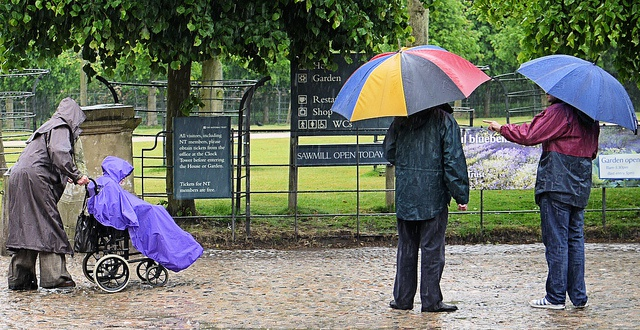Describe the objects in this image and their specific colors. I can see people in darkgreen, black, navy, blue, and gray tones, people in darkgreen, black, navy, darkblue, and gray tones, people in darkgreen, gray, black, darkgray, and lightgray tones, umbrella in darkgreen, gold, lightpink, gray, and lightblue tones, and people in darkgreen, violet, and blue tones in this image. 